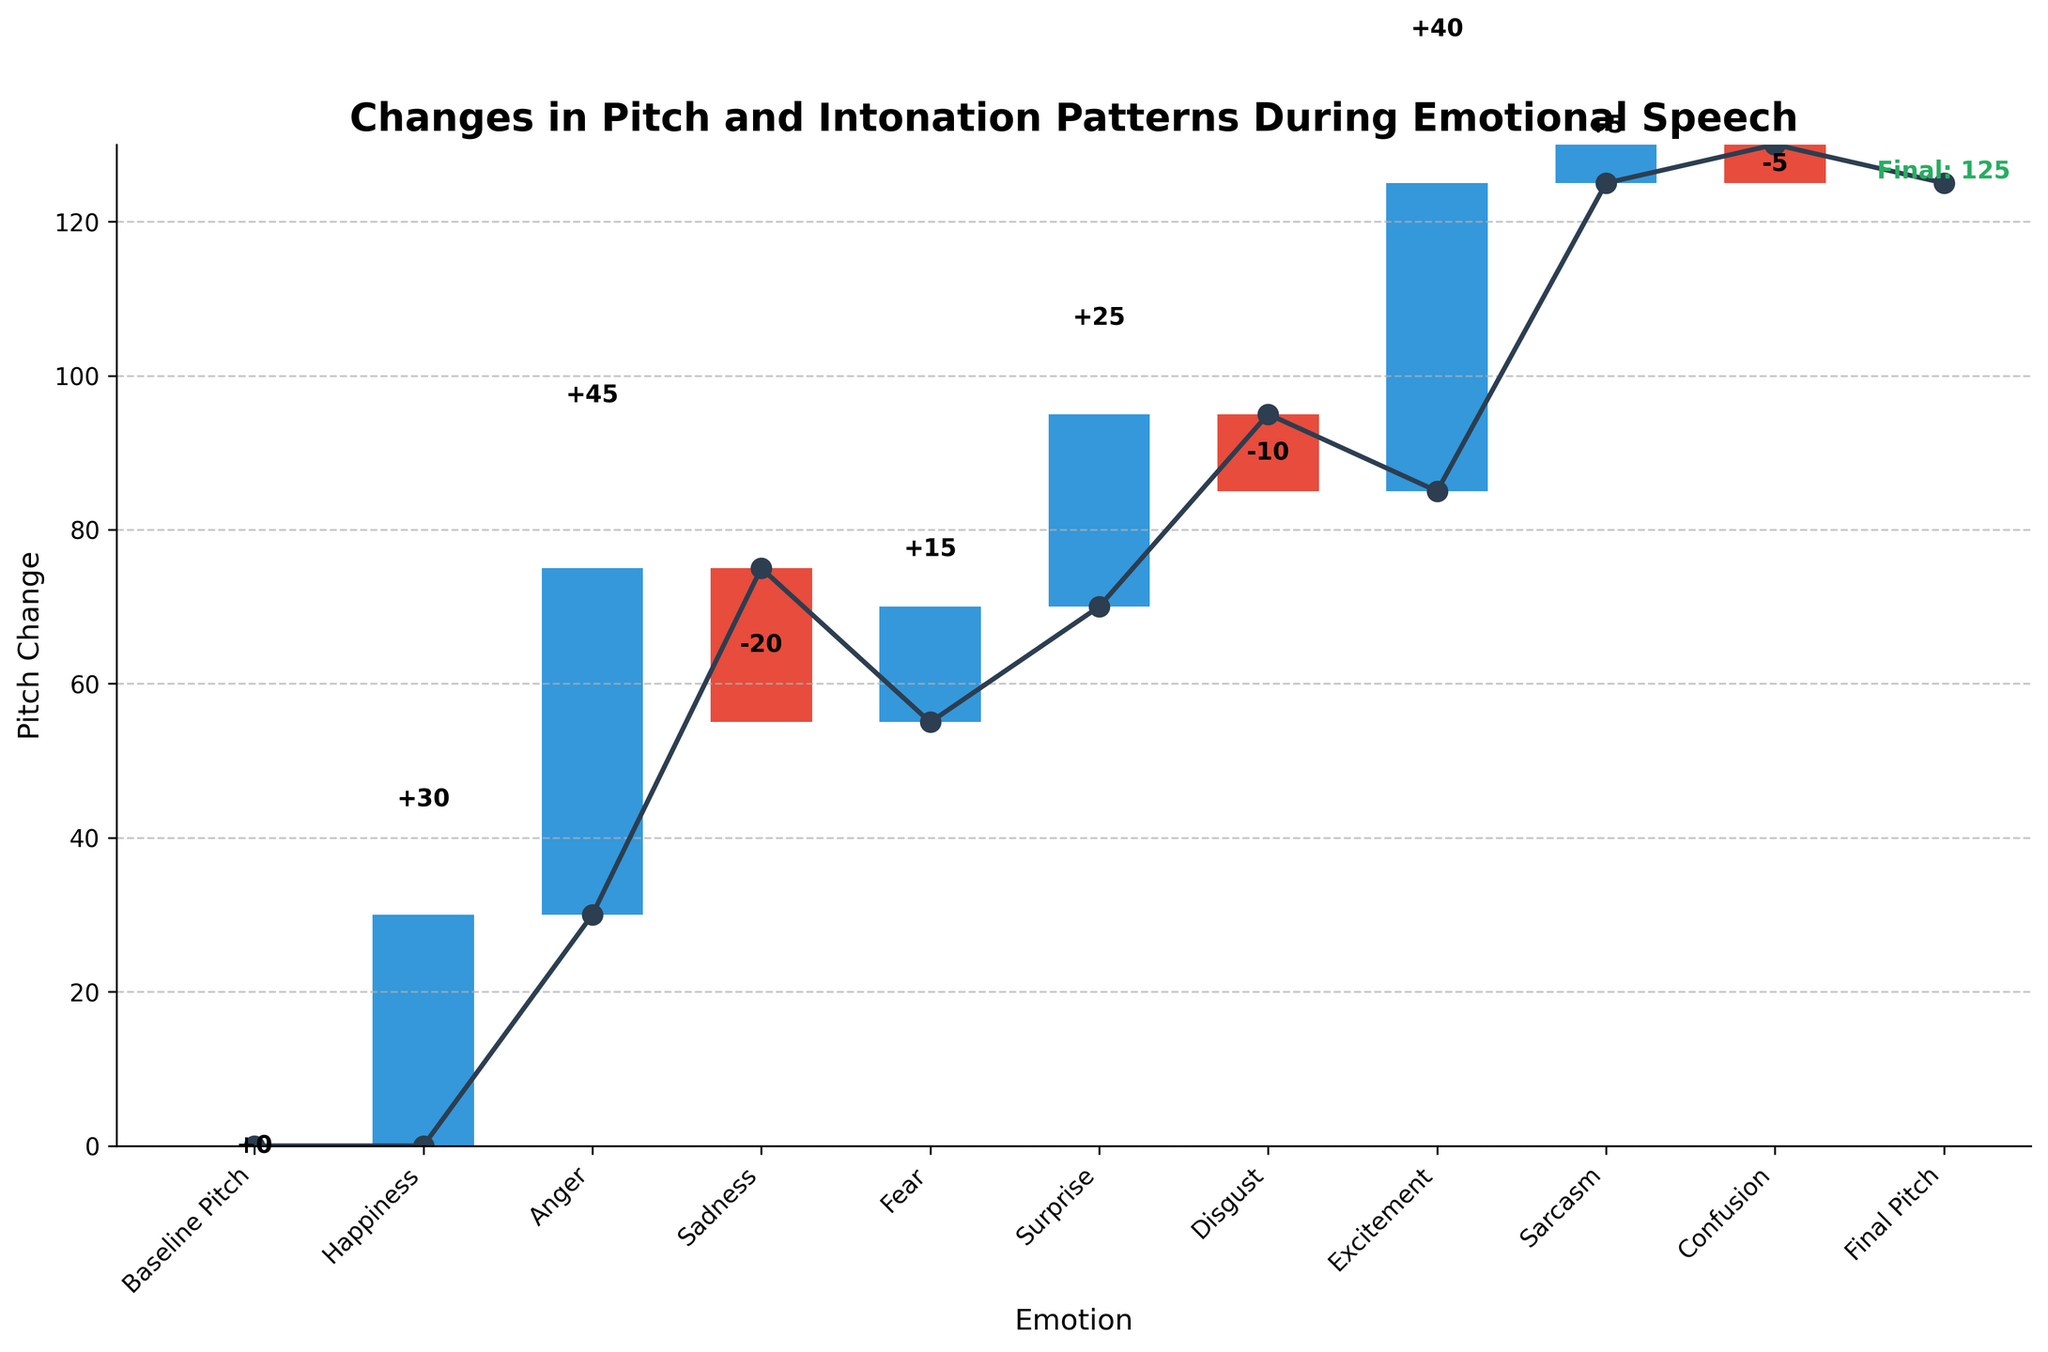What is the title of the figure? The title of the figure is usually located at the top of the chart. In this case, it reads "Changes in Pitch and Intonation Patterns During Emotional Speech."
Answer: Changes in Pitch and Intonation Patterns During Emotional Speech How many emotions are analyzed in the figure? Count the number of categories excluding the Baseline Pitch and Final Pitch. These categories are Happiness, Anger, Sadness, Fear, Surprise, Disgust, Excitement, Sarcasm, and Confusion.
Answer: 9 Which emotion caused the highest increase in pitch? By observing the bars and their corresponding labels, we can see that Anger caused the highest increase in pitch with a change of +45.
Answer: Anger Which emotions resulted in a decrease in pitch? Analyze the bars with negative changes which are Sadness (-20), Disgust (-10), and Confusion (-5).
Answer: Sadness, Disgust, Confusion What is the cumulative pitch change just before the final pitch value? The cumulative pitch change is the sum of all changes excluding the Final Pitch: +0 + 30 + 45 - 20 + 15 + 25 - 10 + 40 + 5 - 5 = 125.
Answer: 125 How does happiness affect pitch compared to sadness? Happiness increases pitch by +30 while Sadness decreases pitch by -20.
Answer: Happiness increases pitch by +30, Sadness decreases pitch by -20 What is the overall trend in pitch changes when experiencing positive emotions like Happiness, Excitement, and Surprise? These emotions each have positive pitch changes: Happiness (+30), Excitement (+40), and Surprise (+25), indicating an overall increase in pitch.
Answer: Increase in pitch Which emotion had the smallest impact on pitch change? Compare the absolute values of the changes for all categories. Confusion has the smallest pitch change with -5.
Answer: Confusion What is the pitch change difference between Excitement and Disgust? Excitement increases pitch by +40 and Disgust decreases pitch by -10. The difference is 40 - (-10) = 50.
Answer: 50 